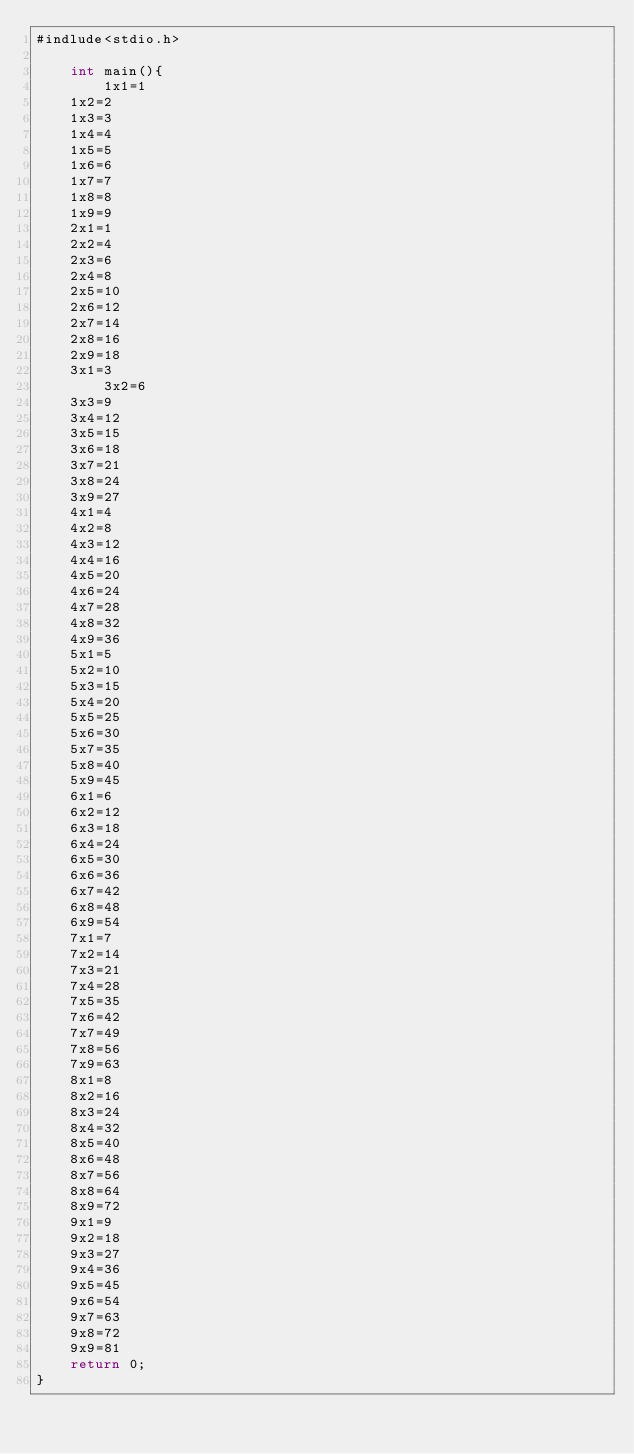<code> <loc_0><loc_0><loc_500><loc_500><_C#_>#indlude<stdio.h>
 
	int main(){
    	1x1=1
	1x2=2
	1x3=3
	1x4=4
	1x5=5
	1x6=6
	1x7=7
	1x8=8
	1x9=9
	2x1=1
	2x2=4
	2x3=6
	2x4=8
	2x5=10
	2x6=12
	2x7=14
	2x8=16
	2x9=18
	3x1=3
        3x2=6
	3x3=9
	3x4=12
	3x5=15
	3x6=18
	3x7=21
	3x8=24
	3x9=27
	4x1=4
	4x2=8
	4x3=12
	4x4=16
	4x5=20
	4x6=24
	4x7=28
	4x8=32
	4x9=36
	5x1=5
	5x2=10
	5x3=15
	5x4=20
	5x5=25
	5x6=30
	5x7=35
	5x8=40
	5x9=45
	6x1=6
	6x2=12
	6x3=18
	6x4=24
	6x5=30
	6x6=36
	6x7=42
	6x8=48
	6x9=54
	7x1=7
	7x2=14
	7x3=21
	7x4=28
	7x5=35
	7x6=42
	7x7=49
	7x8=56
	7x9=63
	8x1=8
	8x2=16
	8x3=24
	8x4=32
	8x5=40
	8x6=48
	8x7=56
	8x8=64
	8x9=72
	9x1=9
	9x2=18
	9x3=27
	9x4=36
	9x5=45
	9x6=54
	9x7=63
	9x8=72
	9x9=81
	return 0;
}</code> 